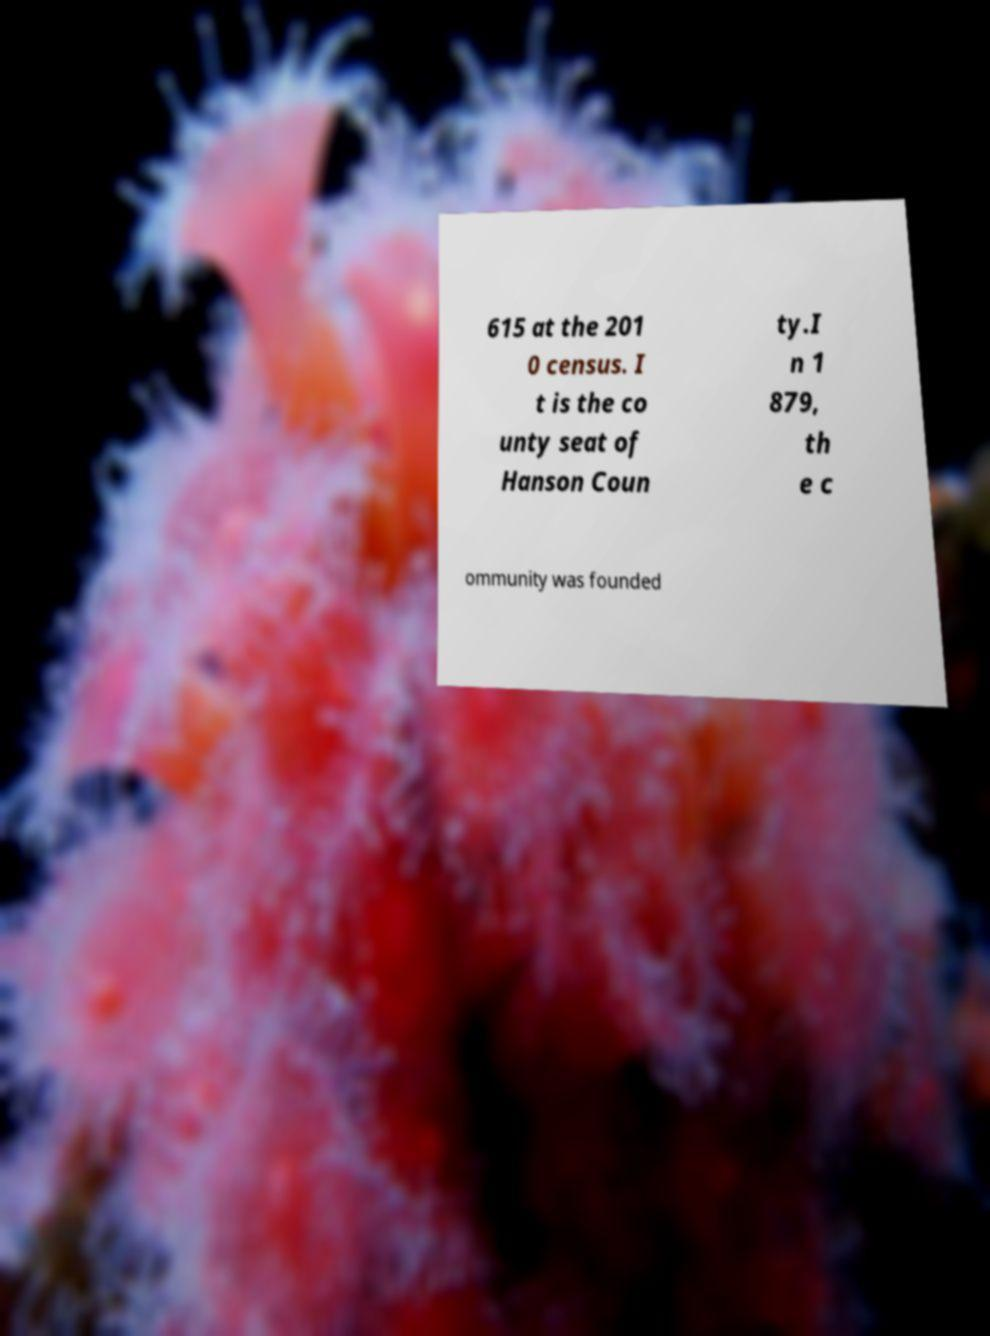Can you accurately transcribe the text from the provided image for me? 615 at the 201 0 census. I t is the co unty seat of Hanson Coun ty.I n 1 879, th e c ommunity was founded 